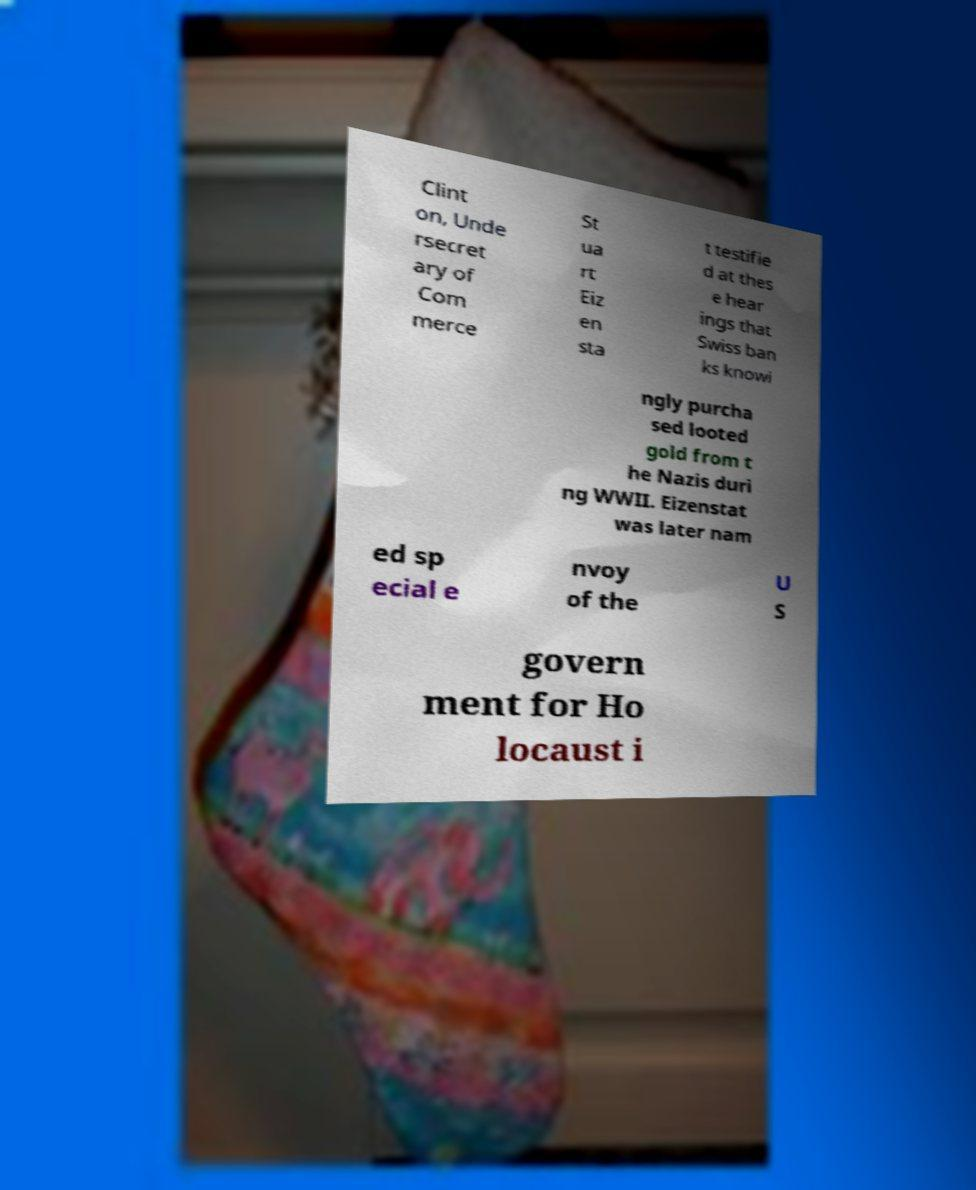Can you read and provide the text displayed in the image?This photo seems to have some interesting text. Can you extract and type it out for me? Clint on, Unde rsecret ary of Com merce St ua rt Eiz en sta t testifie d at thes e hear ings that Swiss ban ks knowi ngly purcha sed looted gold from t he Nazis duri ng WWII. Eizenstat was later nam ed sp ecial e nvoy of the U S govern ment for Ho locaust i 